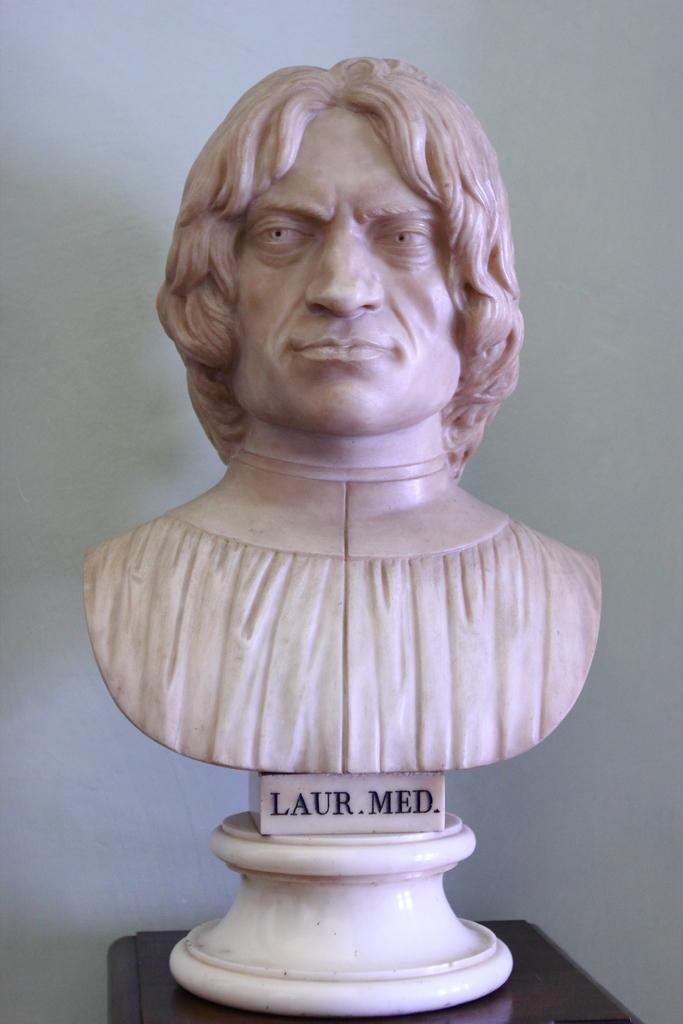What is the main subject of the image? There is a statue of a person in the image. What information is provided about the person depicted in the statue? The name of the person is written on the statue. Where is the statue located? The statue is on a table. What can be seen in the background of the image? There is a white wall in the background of the image. What type of bread is being served at the airport in the image? There is no airport or bread present in the image. Can you tell me how many buttons are on the person's shirt in the image? There is no person wearing a shirt in the image, as it features a statue of a person. 